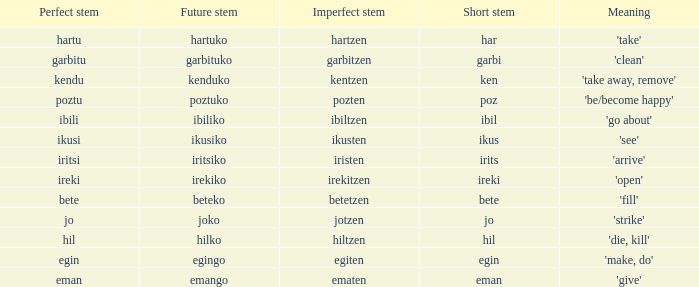What is the perfect stem for pozten? Poztu. 